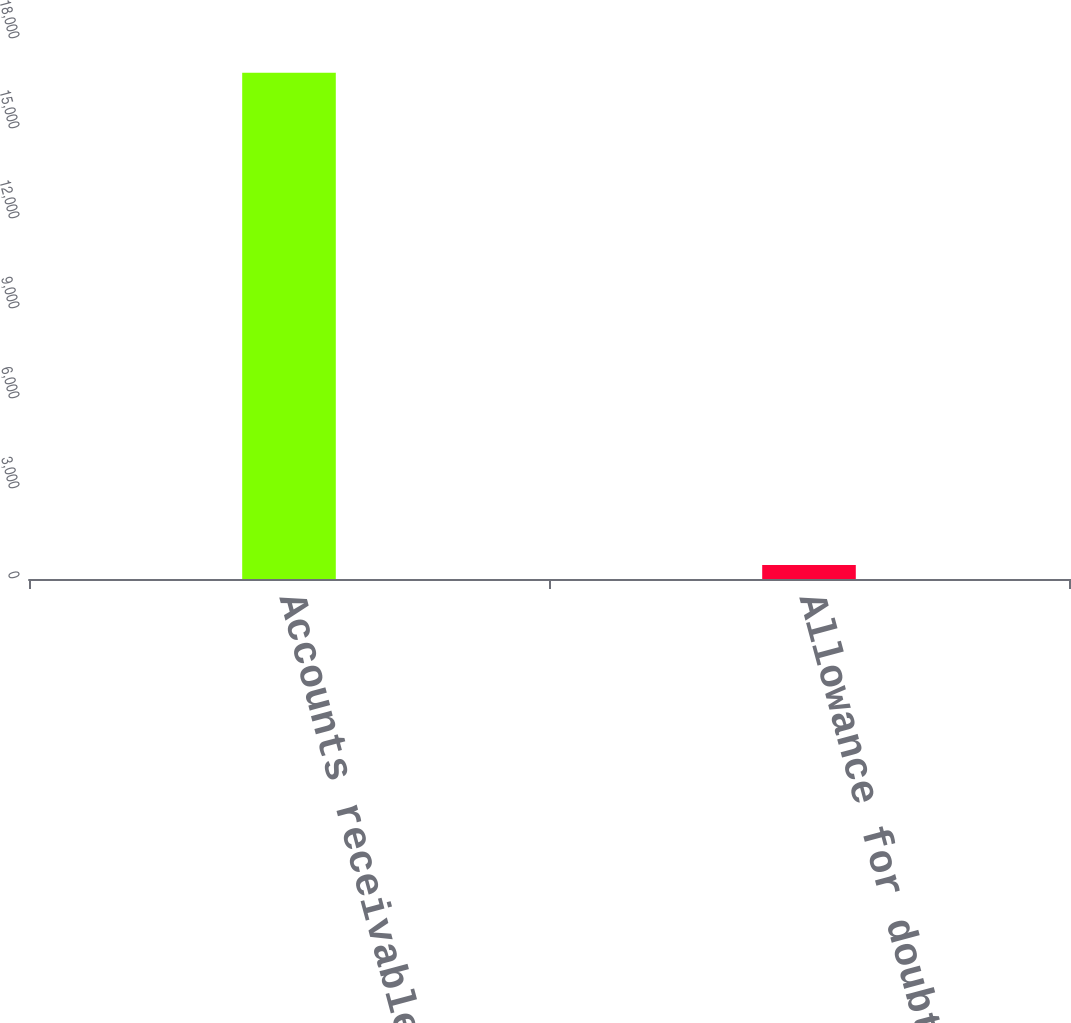Convert chart. <chart><loc_0><loc_0><loc_500><loc_500><bar_chart><fcel>Accounts receivable<fcel>Allowance for doubtful<nl><fcel>16871<fcel>464<nl></chart> 